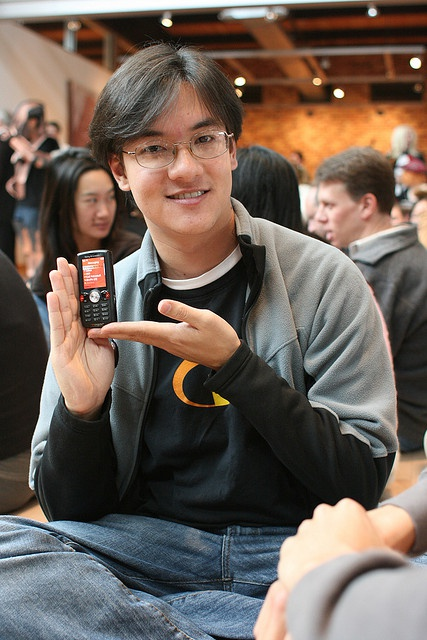Describe the objects in this image and their specific colors. I can see people in darkgray, black, gray, and brown tones, people in darkgray, lightgray, and tan tones, people in darkgray, black, gray, and tan tones, people in darkgray, black, brown, maroon, and gray tones, and people in darkgray, black, gray, and tan tones in this image. 